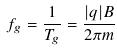<formula> <loc_0><loc_0><loc_500><loc_500>f _ { g } = \frac { 1 } { T _ { g } } = \frac { | q | B } { 2 \pi m }</formula> 